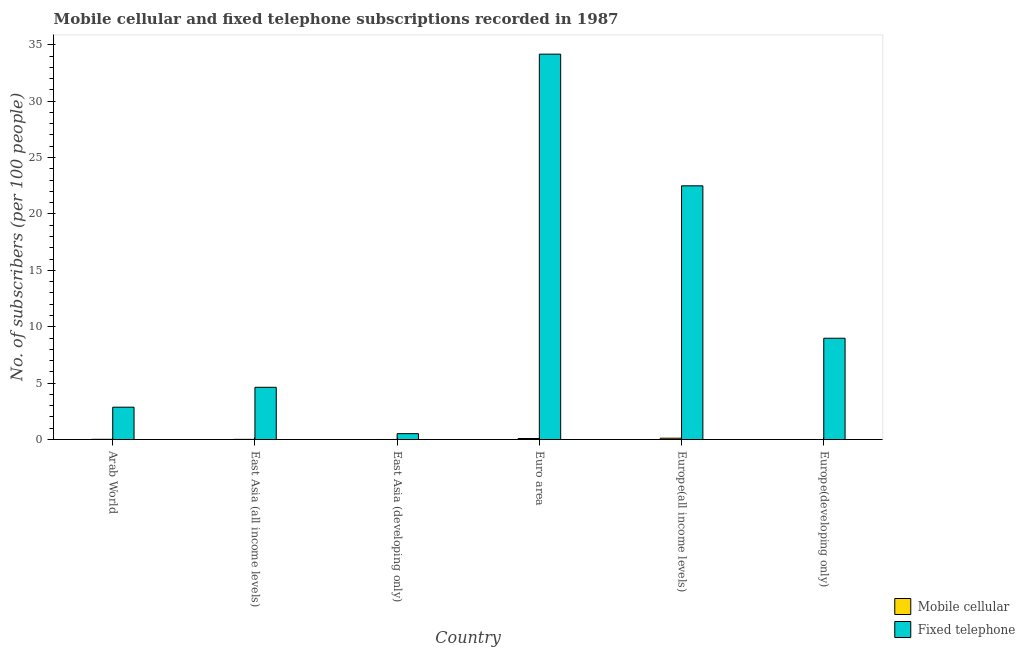How many different coloured bars are there?
Offer a very short reply. 2. How many groups of bars are there?
Provide a short and direct response. 6. How many bars are there on the 5th tick from the left?
Your answer should be compact. 2. How many bars are there on the 3rd tick from the right?
Make the answer very short. 2. What is the label of the 1st group of bars from the left?
Your answer should be compact. Arab World. What is the number of mobile cellular subscribers in East Asia (developing only)?
Keep it short and to the point. 0. Across all countries, what is the maximum number of mobile cellular subscribers?
Make the answer very short. 0.12. Across all countries, what is the minimum number of fixed telephone subscribers?
Offer a terse response. 0.52. In which country was the number of fixed telephone subscribers maximum?
Provide a succinct answer. Euro area. In which country was the number of fixed telephone subscribers minimum?
Your answer should be compact. East Asia (developing only). What is the total number of mobile cellular subscribers in the graph?
Provide a short and direct response. 0.24. What is the difference between the number of mobile cellular subscribers in Arab World and that in Europe(developing only)?
Your answer should be compact. 0.02. What is the difference between the number of mobile cellular subscribers in Euro area and the number of fixed telephone subscribers in East Asia (developing only)?
Your response must be concise. -0.43. What is the average number of fixed telephone subscribers per country?
Give a very brief answer. 12.28. What is the difference between the number of mobile cellular subscribers and number of fixed telephone subscribers in East Asia (all income levels)?
Ensure brevity in your answer.  -4.62. What is the ratio of the number of mobile cellular subscribers in Arab World to that in East Asia (all income levels)?
Make the answer very short. 1.34. Is the difference between the number of fixed telephone subscribers in East Asia (developing only) and Europe(all income levels) greater than the difference between the number of mobile cellular subscribers in East Asia (developing only) and Europe(all income levels)?
Give a very brief answer. No. What is the difference between the highest and the second highest number of mobile cellular subscribers?
Your answer should be compact. 0.03. What is the difference between the highest and the lowest number of mobile cellular subscribers?
Ensure brevity in your answer.  0.11. In how many countries, is the number of mobile cellular subscribers greater than the average number of mobile cellular subscribers taken over all countries?
Provide a succinct answer. 2. Is the sum of the number of fixed telephone subscribers in East Asia (developing only) and Europe(developing only) greater than the maximum number of mobile cellular subscribers across all countries?
Provide a succinct answer. Yes. What does the 1st bar from the left in East Asia (all income levels) represents?
Provide a succinct answer. Mobile cellular. What does the 2nd bar from the right in Arab World represents?
Your answer should be compact. Mobile cellular. How many bars are there?
Offer a terse response. 12. Are all the bars in the graph horizontal?
Keep it short and to the point. No. Are the values on the major ticks of Y-axis written in scientific E-notation?
Offer a terse response. No. Does the graph contain grids?
Offer a terse response. No. What is the title of the graph?
Offer a very short reply. Mobile cellular and fixed telephone subscriptions recorded in 1987. What is the label or title of the X-axis?
Make the answer very short. Country. What is the label or title of the Y-axis?
Your response must be concise. No. of subscribers (per 100 people). What is the No. of subscribers (per 100 people) of Mobile cellular in Arab World?
Make the answer very short. 0.02. What is the No. of subscribers (per 100 people) of Fixed telephone in Arab World?
Give a very brief answer. 2.87. What is the No. of subscribers (per 100 people) in Mobile cellular in East Asia (all income levels)?
Your answer should be very brief. 0.01. What is the No. of subscribers (per 100 people) of Fixed telephone in East Asia (all income levels)?
Your answer should be compact. 4.63. What is the No. of subscribers (per 100 people) of Mobile cellular in East Asia (developing only)?
Give a very brief answer. 0. What is the No. of subscribers (per 100 people) in Fixed telephone in East Asia (developing only)?
Your answer should be compact. 0.52. What is the No. of subscribers (per 100 people) of Mobile cellular in Euro area?
Offer a terse response. 0.09. What is the No. of subscribers (per 100 people) of Fixed telephone in Euro area?
Provide a short and direct response. 34.17. What is the No. of subscribers (per 100 people) in Mobile cellular in Europe(all income levels)?
Offer a terse response. 0.12. What is the No. of subscribers (per 100 people) in Fixed telephone in Europe(all income levels)?
Make the answer very short. 22.49. What is the No. of subscribers (per 100 people) in Mobile cellular in Europe(developing only)?
Provide a succinct answer. 0. What is the No. of subscribers (per 100 people) in Fixed telephone in Europe(developing only)?
Offer a terse response. 8.98. Across all countries, what is the maximum No. of subscribers (per 100 people) in Mobile cellular?
Your answer should be very brief. 0.12. Across all countries, what is the maximum No. of subscribers (per 100 people) in Fixed telephone?
Your answer should be compact. 34.17. Across all countries, what is the minimum No. of subscribers (per 100 people) of Mobile cellular?
Keep it short and to the point. 0. Across all countries, what is the minimum No. of subscribers (per 100 people) in Fixed telephone?
Keep it short and to the point. 0.52. What is the total No. of subscribers (per 100 people) of Mobile cellular in the graph?
Offer a terse response. 0.24. What is the total No. of subscribers (per 100 people) of Fixed telephone in the graph?
Offer a terse response. 73.65. What is the difference between the No. of subscribers (per 100 people) in Mobile cellular in Arab World and that in East Asia (all income levels)?
Your answer should be very brief. 0. What is the difference between the No. of subscribers (per 100 people) in Fixed telephone in Arab World and that in East Asia (all income levels)?
Your answer should be very brief. -1.76. What is the difference between the No. of subscribers (per 100 people) of Mobile cellular in Arab World and that in East Asia (developing only)?
Offer a very short reply. 0.02. What is the difference between the No. of subscribers (per 100 people) in Fixed telephone in Arab World and that in East Asia (developing only)?
Your response must be concise. 2.35. What is the difference between the No. of subscribers (per 100 people) in Mobile cellular in Arab World and that in Euro area?
Offer a very short reply. -0.07. What is the difference between the No. of subscribers (per 100 people) in Fixed telephone in Arab World and that in Euro area?
Provide a succinct answer. -31.3. What is the difference between the No. of subscribers (per 100 people) in Mobile cellular in Arab World and that in Europe(all income levels)?
Provide a short and direct response. -0.1. What is the difference between the No. of subscribers (per 100 people) of Fixed telephone in Arab World and that in Europe(all income levels)?
Offer a very short reply. -19.62. What is the difference between the No. of subscribers (per 100 people) in Mobile cellular in Arab World and that in Europe(developing only)?
Keep it short and to the point. 0.02. What is the difference between the No. of subscribers (per 100 people) in Fixed telephone in Arab World and that in Europe(developing only)?
Offer a very short reply. -6.11. What is the difference between the No. of subscribers (per 100 people) of Mobile cellular in East Asia (all income levels) and that in East Asia (developing only)?
Provide a short and direct response. 0.01. What is the difference between the No. of subscribers (per 100 people) of Fixed telephone in East Asia (all income levels) and that in East Asia (developing only)?
Keep it short and to the point. 4.11. What is the difference between the No. of subscribers (per 100 people) of Mobile cellular in East Asia (all income levels) and that in Euro area?
Your response must be concise. -0.08. What is the difference between the No. of subscribers (per 100 people) in Fixed telephone in East Asia (all income levels) and that in Euro area?
Your answer should be compact. -29.54. What is the difference between the No. of subscribers (per 100 people) in Mobile cellular in East Asia (all income levels) and that in Europe(all income levels)?
Your response must be concise. -0.1. What is the difference between the No. of subscribers (per 100 people) of Fixed telephone in East Asia (all income levels) and that in Europe(all income levels)?
Make the answer very short. -17.86. What is the difference between the No. of subscribers (per 100 people) in Mobile cellular in East Asia (all income levels) and that in Europe(developing only)?
Give a very brief answer. 0.01. What is the difference between the No. of subscribers (per 100 people) of Fixed telephone in East Asia (all income levels) and that in Europe(developing only)?
Make the answer very short. -4.35. What is the difference between the No. of subscribers (per 100 people) of Mobile cellular in East Asia (developing only) and that in Euro area?
Offer a terse response. -0.09. What is the difference between the No. of subscribers (per 100 people) of Fixed telephone in East Asia (developing only) and that in Euro area?
Offer a very short reply. -33.65. What is the difference between the No. of subscribers (per 100 people) in Mobile cellular in East Asia (developing only) and that in Europe(all income levels)?
Give a very brief answer. -0.11. What is the difference between the No. of subscribers (per 100 people) of Fixed telephone in East Asia (developing only) and that in Europe(all income levels)?
Your response must be concise. -21.97. What is the difference between the No. of subscribers (per 100 people) of Mobile cellular in East Asia (developing only) and that in Europe(developing only)?
Offer a very short reply. -0. What is the difference between the No. of subscribers (per 100 people) in Fixed telephone in East Asia (developing only) and that in Europe(developing only)?
Offer a terse response. -8.46. What is the difference between the No. of subscribers (per 100 people) in Mobile cellular in Euro area and that in Europe(all income levels)?
Give a very brief answer. -0.03. What is the difference between the No. of subscribers (per 100 people) of Fixed telephone in Euro area and that in Europe(all income levels)?
Offer a terse response. 11.67. What is the difference between the No. of subscribers (per 100 people) of Mobile cellular in Euro area and that in Europe(developing only)?
Offer a terse response. 0.09. What is the difference between the No. of subscribers (per 100 people) of Fixed telephone in Euro area and that in Europe(developing only)?
Offer a very short reply. 25.19. What is the difference between the No. of subscribers (per 100 people) in Mobile cellular in Europe(all income levels) and that in Europe(developing only)?
Your response must be concise. 0.11. What is the difference between the No. of subscribers (per 100 people) of Fixed telephone in Europe(all income levels) and that in Europe(developing only)?
Your answer should be very brief. 13.51. What is the difference between the No. of subscribers (per 100 people) of Mobile cellular in Arab World and the No. of subscribers (per 100 people) of Fixed telephone in East Asia (all income levels)?
Keep it short and to the point. -4.61. What is the difference between the No. of subscribers (per 100 people) of Mobile cellular in Arab World and the No. of subscribers (per 100 people) of Fixed telephone in East Asia (developing only)?
Provide a succinct answer. -0.5. What is the difference between the No. of subscribers (per 100 people) of Mobile cellular in Arab World and the No. of subscribers (per 100 people) of Fixed telephone in Euro area?
Offer a very short reply. -34.15. What is the difference between the No. of subscribers (per 100 people) in Mobile cellular in Arab World and the No. of subscribers (per 100 people) in Fixed telephone in Europe(all income levels)?
Provide a succinct answer. -22.47. What is the difference between the No. of subscribers (per 100 people) in Mobile cellular in Arab World and the No. of subscribers (per 100 people) in Fixed telephone in Europe(developing only)?
Ensure brevity in your answer.  -8.96. What is the difference between the No. of subscribers (per 100 people) in Mobile cellular in East Asia (all income levels) and the No. of subscribers (per 100 people) in Fixed telephone in East Asia (developing only)?
Offer a terse response. -0.51. What is the difference between the No. of subscribers (per 100 people) in Mobile cellular in East Asia (all income levels) and the No. of subscribers (per 100 people) in Fixed telephone in Euro area?
Offer a terse response. -34.15. What is the difference between the No. of subscribers (per 100 people) of Mobile cellular in East Asia (all income levels) and the No. of subscribers (per 100 people) of Fixed telephone in Europe(all income levels)?
Provide a short and direct response. -22.48. What is the difference between the No. of subscribers (per 100 people) in Mobile cellular in East Asia (all income levels) and the No. of subscribers (per 100 people) in Fixed telephone in Europe(developing only)?
Ensure brevity in your answer.  -8.97. What is the difference between the No. of subscribers (per 100 people) in Mobile cellular in East Asia (developing only) and the No. of subscribers (per 100 people) in Fixed telephone in Euro area?
Your answer should be very brief. -34.16. What is the difference between the No. of subscribers (per 100 people) in Mobile cellular in East Asia (developing only) and the No. of subscribers (per 100 people) in Fixed telephone in Europe(all income levels)?
Offer a terse response. -22.49. What is the difference between the No. of subscribers (per 100 people) in Mobile cellular in East Asia (developing only) and the No. of subscribers (per 100 people) in Fixed telephone in Europe(developing only)?
Make the answer very short. -8.98. What is the difference between the No. of subscribers (per 100 people) in Mobile cellular in Euro area and the No. of subscribers (per 100 people) in Fixed telephone in Europe(all income levels)?
Your answer should be very brief. -22.4. What is the difference between the No. of subscribers (per 100 people) of Mobile cellular in Euro area and the No. of subscribers (per 100 people) of Fixed telephone in Europe(developing only)?
Provide a short and direct response. -8.89. What is the difference between the No. of subscribers (per 100 people) of Mobile cellular in Europe(all income levels) and the No. of subscribers (per 100 people) of Fixed telephone in Europe(developing only)?
Make the answer very short. -8.86. What is the average No. of subscribers (per 100 people) of Mobile cellular per country?
Make the answer very short. 0.04. What is the average No. of subscribers (per 100 people) of Fixed telephone per country?
Make the answer very short. 12.28. What is the difference between the No. of subscribers (per 100 people) of Mobile cellular and No. of subscribers (per 100 people) of Fixed telephone in Arab World?
Provide a succinct answer. -2.85. What is the difference between the No. of subscribers (per 100 people) in Mobile cellular and No. of subscribers (per 100 people) in Fixed telephone in East Asia (all income levels)?
Make the answer very short. -4.62. What is the difference between the No. of subscribers (per 100 people) in Mobile cellular and No. of subscribers (per 100 people) in Fixed telephone in East Asia (developing only)?
Offer a terse response. -0.52. What is the difference between the No. of subscribers (per 100 people) of Mobile cellular and No. of subscribers (per 100 people) of Fixed telephone in Euro area?
Your response must be concise. -34.08. What is the difference between the No. of subscribers (per 100 people) of Mobile cellular and No. of subscribers (per 100 people) of Fixed telephone in Europe(all income levels)?
Provide a succinct answer. -22.38. What is the difference between the No. of subscribers (per 100 people) of Mobile cellular and No. of subscribers (per 100 people) of Fixed telephone in Europe(developing only)?
Provide a succinct answer. -8.98. What is the ratio of the No. of subscribers (per 100 people) in Mobile cellular in Arab World to that in East Asia (all income levels)?
Offer a very short reply. 1.34. What is the ratio of the No. of subscribers (per 100 people) in Fixed telephone in Arab World to that in East Asia (all income levels)?
Your answer should be compact. 0.62. What is the ratio of the No. of subscribers (per 100 people) of Mobile cellular in Arab World to that in East Asia (developing only)?
Give a very brief answer. 8.84. What is the ratio of the No. of subscribers (per 100 people) of Fixed telephone in Arab World to that in East Asia (developing only)?
Your answer should be very brief. 5.51. What is the ratio of the No. of subscribers (per 100 people) in Mobile cellular in Arab World to that in Euro area?
Your answer should be compact. 0.19. What is the ratio of the No. of subscribers (per 100 people) of Fixed telephone in Arab World to that in Euro area?
Your response must be concise. 0.08. What is the ratio of the No. of subscribers (per 100 people) in Mobile cellular in Arab World to that in Europe(all income levels)?
Offer a very short reply. 0.15. What is the ratio of the No. of subscribers (per 100 people) of Fixed telephone in Arab World to that in Europe(all income levels)?
Ensure brevity in your answer.  0.13. What is the ratio of the No. of subscribers (per 100 people) of Mobile cellular in Arab World to that in Europe(developing only)?
Keep it short and to the point. 7.55. What is the ratio of the No. of subscribers (per 100 people) in Fixed telephone in Arab World to that in Europe(developing only)?
Keep it short and to the point. 0.32. What is the ratio of the No. of subscribers (per 100 people) in Mobile cellular in East Asia (all income levels) to that in East Asia (developing only)?
Offer a terse response. 6.57. What is the ratio of the No. of subscribers (per 100 people) in Fixed telephone in East Asia (all income levels) to that in East Asia (developing only)?
Give a very brief answer. 8.9. What is the ratio of the No. of subscribers (per 100 people) of Mobile cellular in East Asia (all income levels) to that in Euro area?
Keep it short and to the point. 0.14. What is the ratio of the No. of subscribers (per 100 people) of Fixed telephone in East Asia (all income levels) to that in Euro area?
Provide a short and direct response. 0.14. What is the ratio of the No. of subscribers (per 100 people) of Mobile cellular in East Asia (all income levels) to that in Europe(all income levels)?
Give a very brief answer. 0.11. What is the ratio of the No. of subscribers (per 100 people) in Fixed telephone in East Asia (all income levels) to that in Europe(all income levels)?
Your answer should be very brief. 0.21. What is the ratio of the No. of subscribers (per 100 people) in Mobile cellular in East Asia (all income levels) to that in Europe(developing only)?
Your response must be concise. 5.61. What is the ratio of the No. of subscribers (per 100 people) in Fixed telephone in East Asia (all income levels) to that in Europe(developing only)?
Keep it short and to the point. 0.52. What is the ratio of the No. of subscribers (per 100 people) of Mobile cellular in East Asia (developing only) to that in Euro area?
Keep it short and to the point. 0.02. What is the ratio of the No. of subscribers (per 100 people) of Fixed telephone in East Asia (developing only) to that in Euro area?
Offer a terse response. 0.02. What is the ratio of the No. of subscribers (per 100 people) of Mobile cellular in East Asia (developing only) to that in Europe(all income levels)?
Your answer should be very brief. 0.02. What is the ratio of the No. of subscribers (per 100 people) in Fixed telephone in East Asia (developing only) to that in Europe(all income levels)?
Your response must be concise. 0.02. What is the ratio of the No. of subscribers (per 100 people) in Mobile cellular in East Asia (developing only) to that in Europe(developing only)?
Make the answer very short. 0.85. What is the ratio of the No. of subscribers (per 100 people) of Fixed telephone in East Asia (developing only) to that in Europe(developing only)?
Provide a short and direct response. 0.06. What is the ratio of the No. of subscribers (per 100 people) of Mobile cellular in Euro area to that in Europe(all income levels)?
Make the answer very short. 0.77. What is the ratio of the No. of subscribers (per 100 people) of Fixed telephone in Euro area to that in Europe(all income levels)?
Offer a terse response. 1.52. What is the ratio of the No. of subscribers (per 100 people) in Mobile cellular in Euro area to that in Europe(developing only)?
Provide a short and direct response. 39. What is the ratio of the No. of subscribers (per 100 people) of Fixed telephone in Euro area to that in Europe(developing only)?
Offer a very short reply. 3.81. What is the ratio of the No. of subscribers (per 100 people) in Mobile cellular in Europe(all income levels) to that in Europe(developing only)?
Offer a very short reply. 50.52. What is the ratio of the No. of subscribers (per 100 people) of Fixed telephone in Europe(all income levels) to that in Europe(developing only)?
Your answer should be compact. 2.5. What is the difference between the highest and the second highest No. of subscribers (per 100 people) of Mobile cellular?
Ensure brevity in your answer.  0.03. What is the difference between the highest and the second highest No. of subscribers (per 100 people) in Fixed telephone?
Keep it short and to the point. 11.67. What is the difference between the highest and the lowest No. of subscribers (per 100 people) in Mobile cellular?
Offer a very short reply. 0.11. What is the difference between the highest and the lowest No. of subscribers (per 100 people) of Fixed telephone?
Make the answer very short. 33.65. 